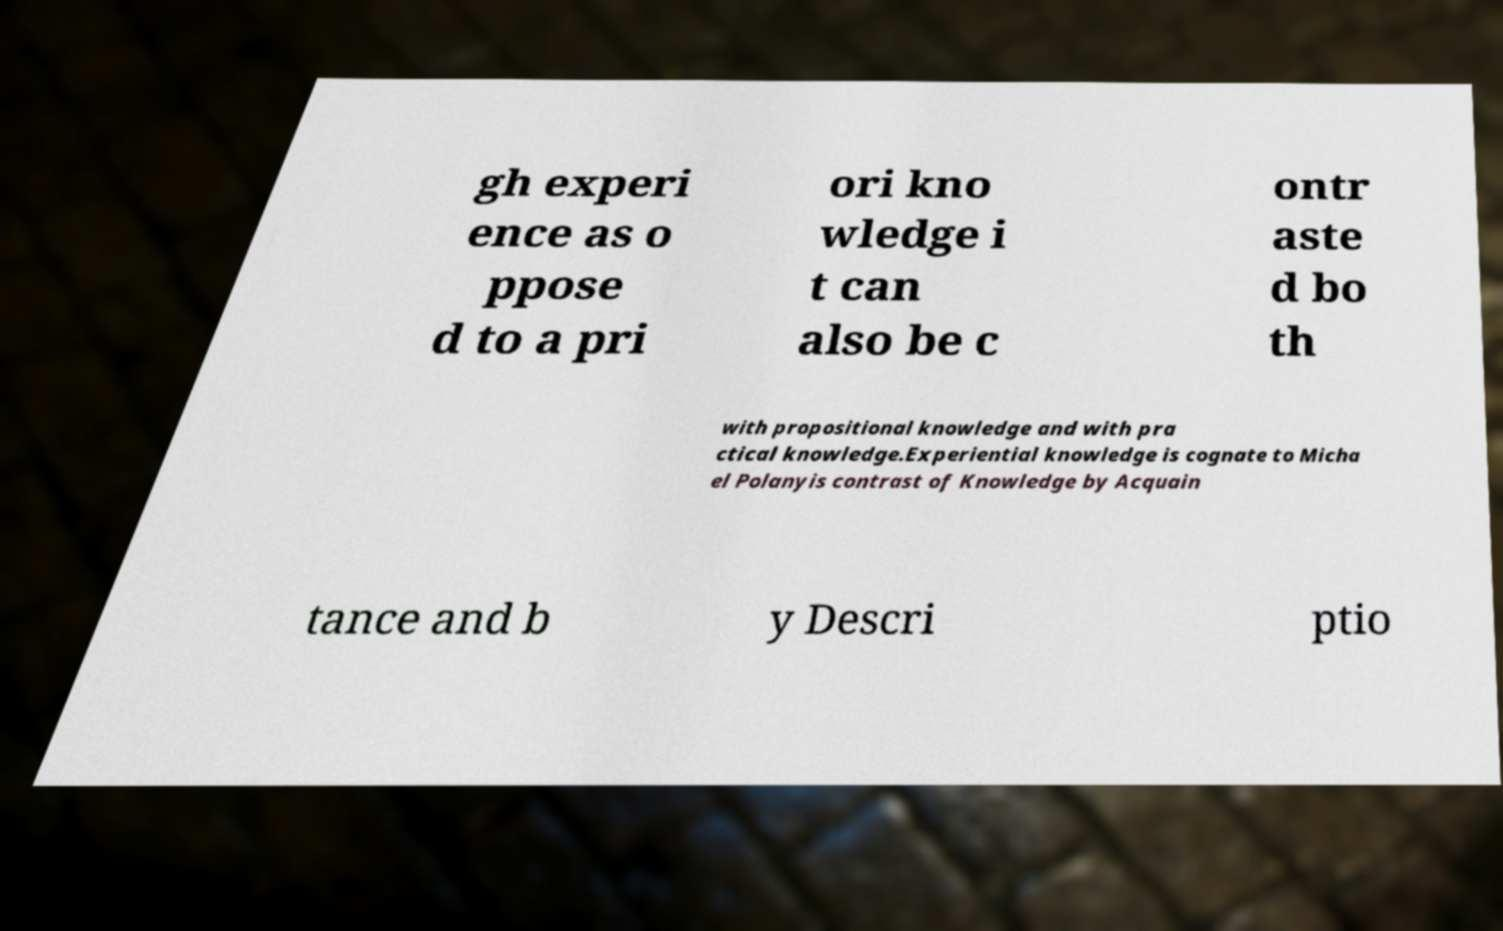What messages or text are displayed in this image? I need them in a readable, typed format. gh experi ence as o ppose d to a pri ori kno wledge i t can also be c ontr aste d bo th with propositional knowledge and with pra ctical knowledge.Experiential knowledge is cognate to Micha el Polanyis contrast of Knowledge by Acquain tance and b y Descri ptio 